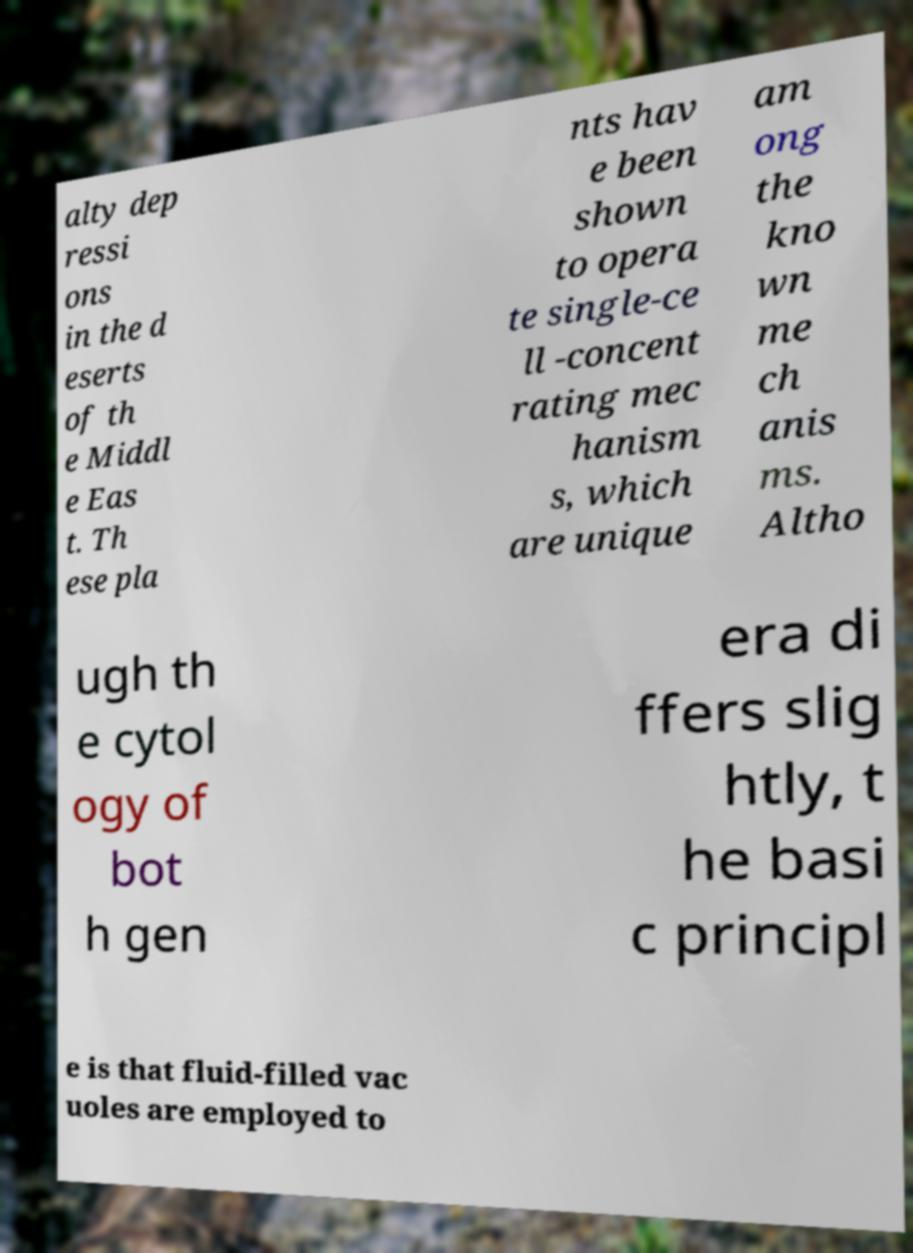What messages or text are displayed in this image? I need them in a readable, typed format. alty dep ressi ons in the d eserts of th e Middl e Eas t. Th ese pla nts hav e been shown to opera te single-ce ll -concent rating mec hanism s, which are unique am ong the kno wn me ch anis ms. Altho ugh th e cytol ogy of bot h gen era di ffers slig htly, t he basi c principl e is that fluid-filled vac uoles are employed to 